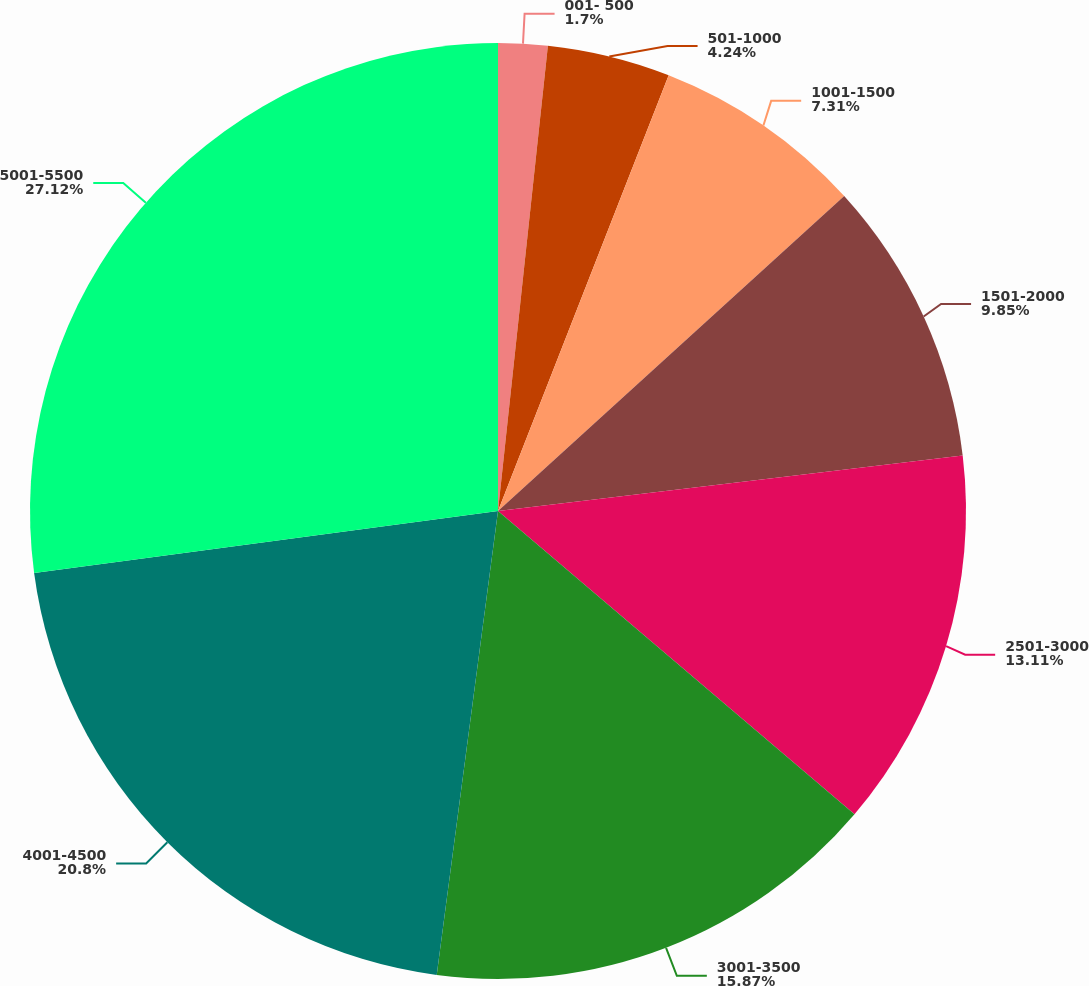Convert chart. <chart><loc_0><loc_0><loc_500><loc_500><pie_chart><fcel>001- 500<fcel>501-1000<fcel>1001-1500<fcel>1501-2000<fcel>2501-3000<fcel>3001-3500<fcel>4001-4500<fcel>5001-5500<nl><fcel>1.7%<fcel>4.24%<fcel>7.31%<fcel>9.85%<fcel>13.11%<fcel>15.87%<fcel>20.79%<fcel>27.11%<nl></chart> 